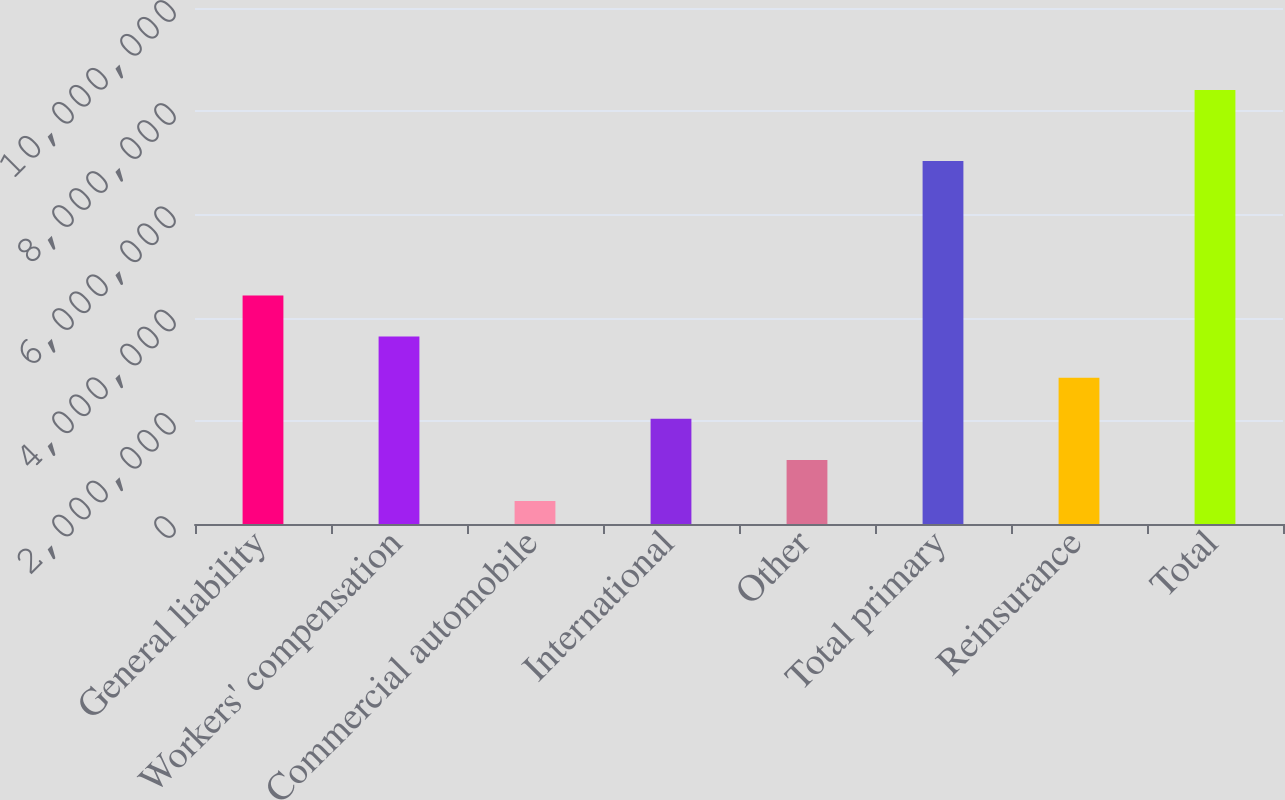<chart> <loc_0><loc_0><loc_500><loc_500><bar_chart><fcel>General liability<fcel>Workers' compensation<fcel>Commercial automobile<fcel>International<fcel>Other<fcel>Total primary<fcel>Reinsurance<fcel>Total<nl><fcel>4.4284e+06<fcel>3.63171e+06<fcel>444957<fcel>2.03834e+06<fcel>1.24165e+06<fcel>7.03423e+06<fcel>2.83503e+06<fcel>8.41185e+06<nl></chart> 